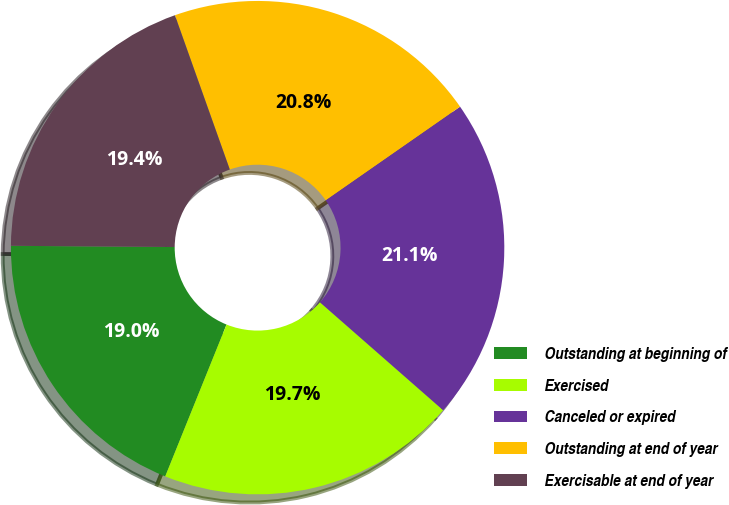Convert chart. <chart><loc_0><loc_0><loc_500><loc_500><pie_chart><fcel>Outstanding at beginning of<fcel>Exercised<fcel>Canceled or expired<fcel>Outstanding at end of year<fcel>Exercisable at end of year<nl><fcel>19.01%<fcel>19.66%<fcel>21.13%<fcel>20.76%<fcel>19.44%<nl></chart> 